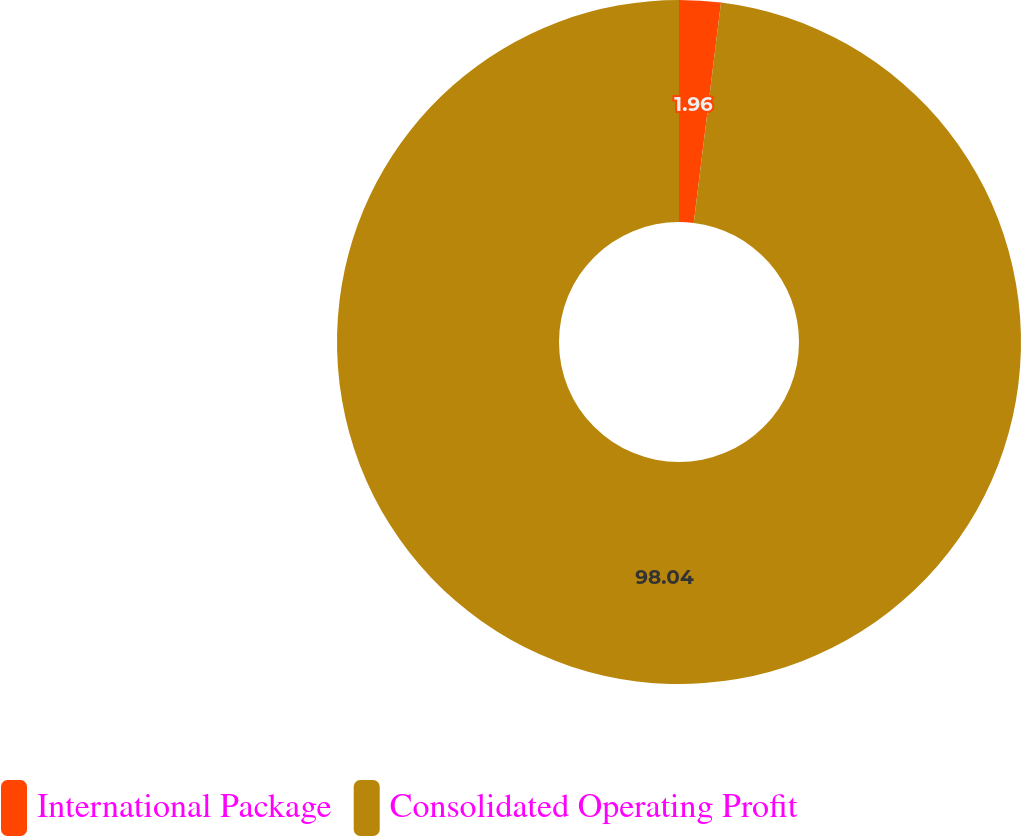<chart> <loc_0><loc_0><loc_500><loc_500><pie_chart><fcel>International Package<fcel>Consolidated Operating Profit<nl><fcel>1.96%<fcel>98.04%<nl></chart> 